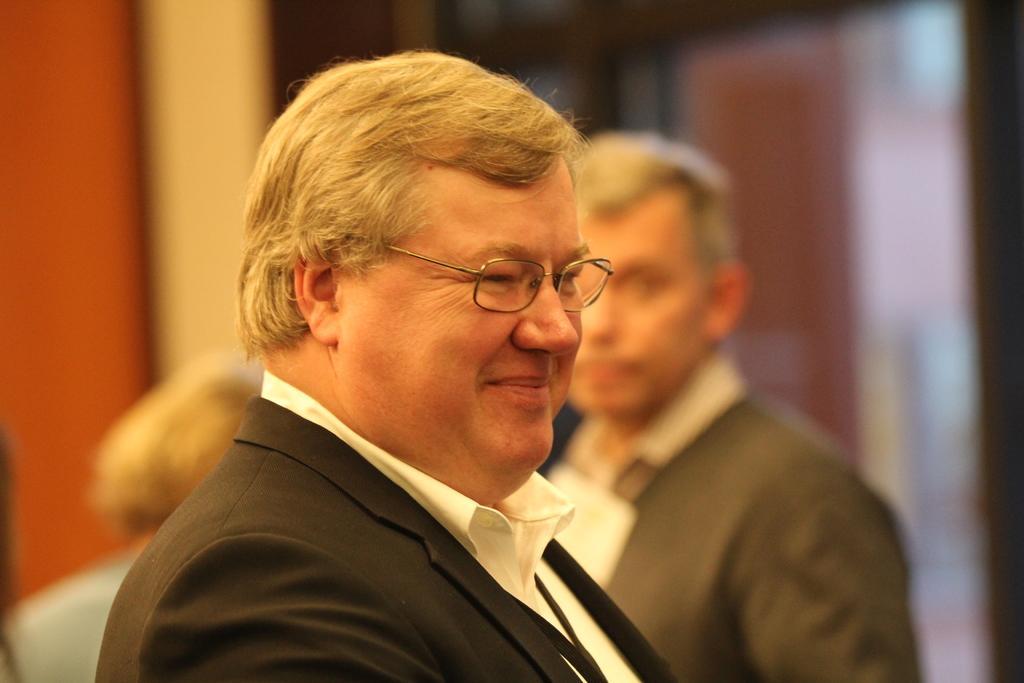Describe this image in one or two sentences. In the front of the image I can see a person smiling and wearing spectacles. In the background of the image it is blurry and there are people.  